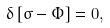Convert formula to latex. <formula><loc_0><loc_0><loc_500><loc_500>\delta \left [ \sigma - \Phi \right ] = 0 ,</formula> 